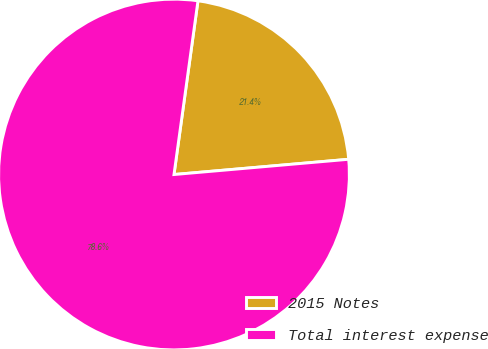Convert chart. <chart><loc_0><loc_0><loc_500><loc_500><pie_chart><fcel>2015 Notes<fcel>Total interest expense<nl><fcel>21.43%<fcel>78.57%<nl></chart> 